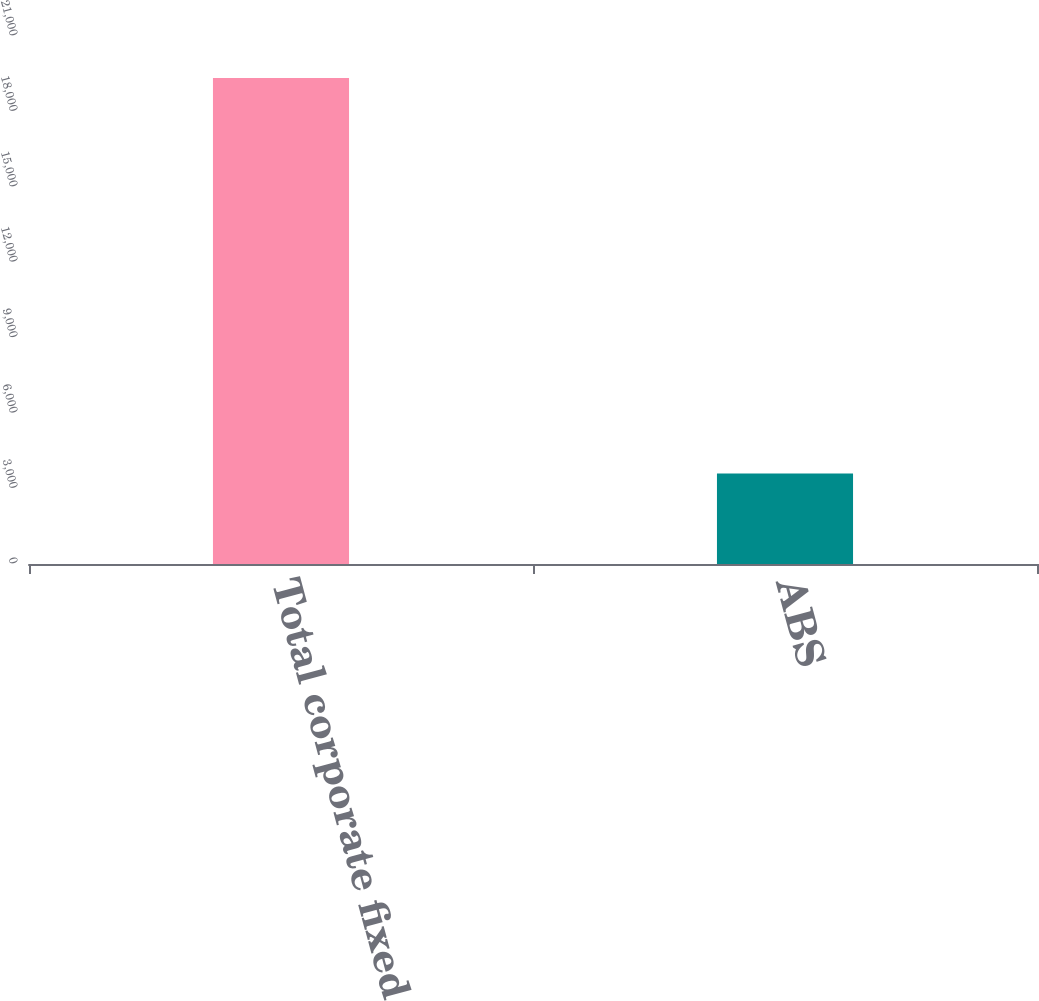Convert chart to OTSL. <chart><loc_0><loc_0><loc_500><loc_500><bar_chart><fcel>Total corporate fixed income<fcel>ABS<nl><fcel>19330<fcel>3595<nl></chart> 